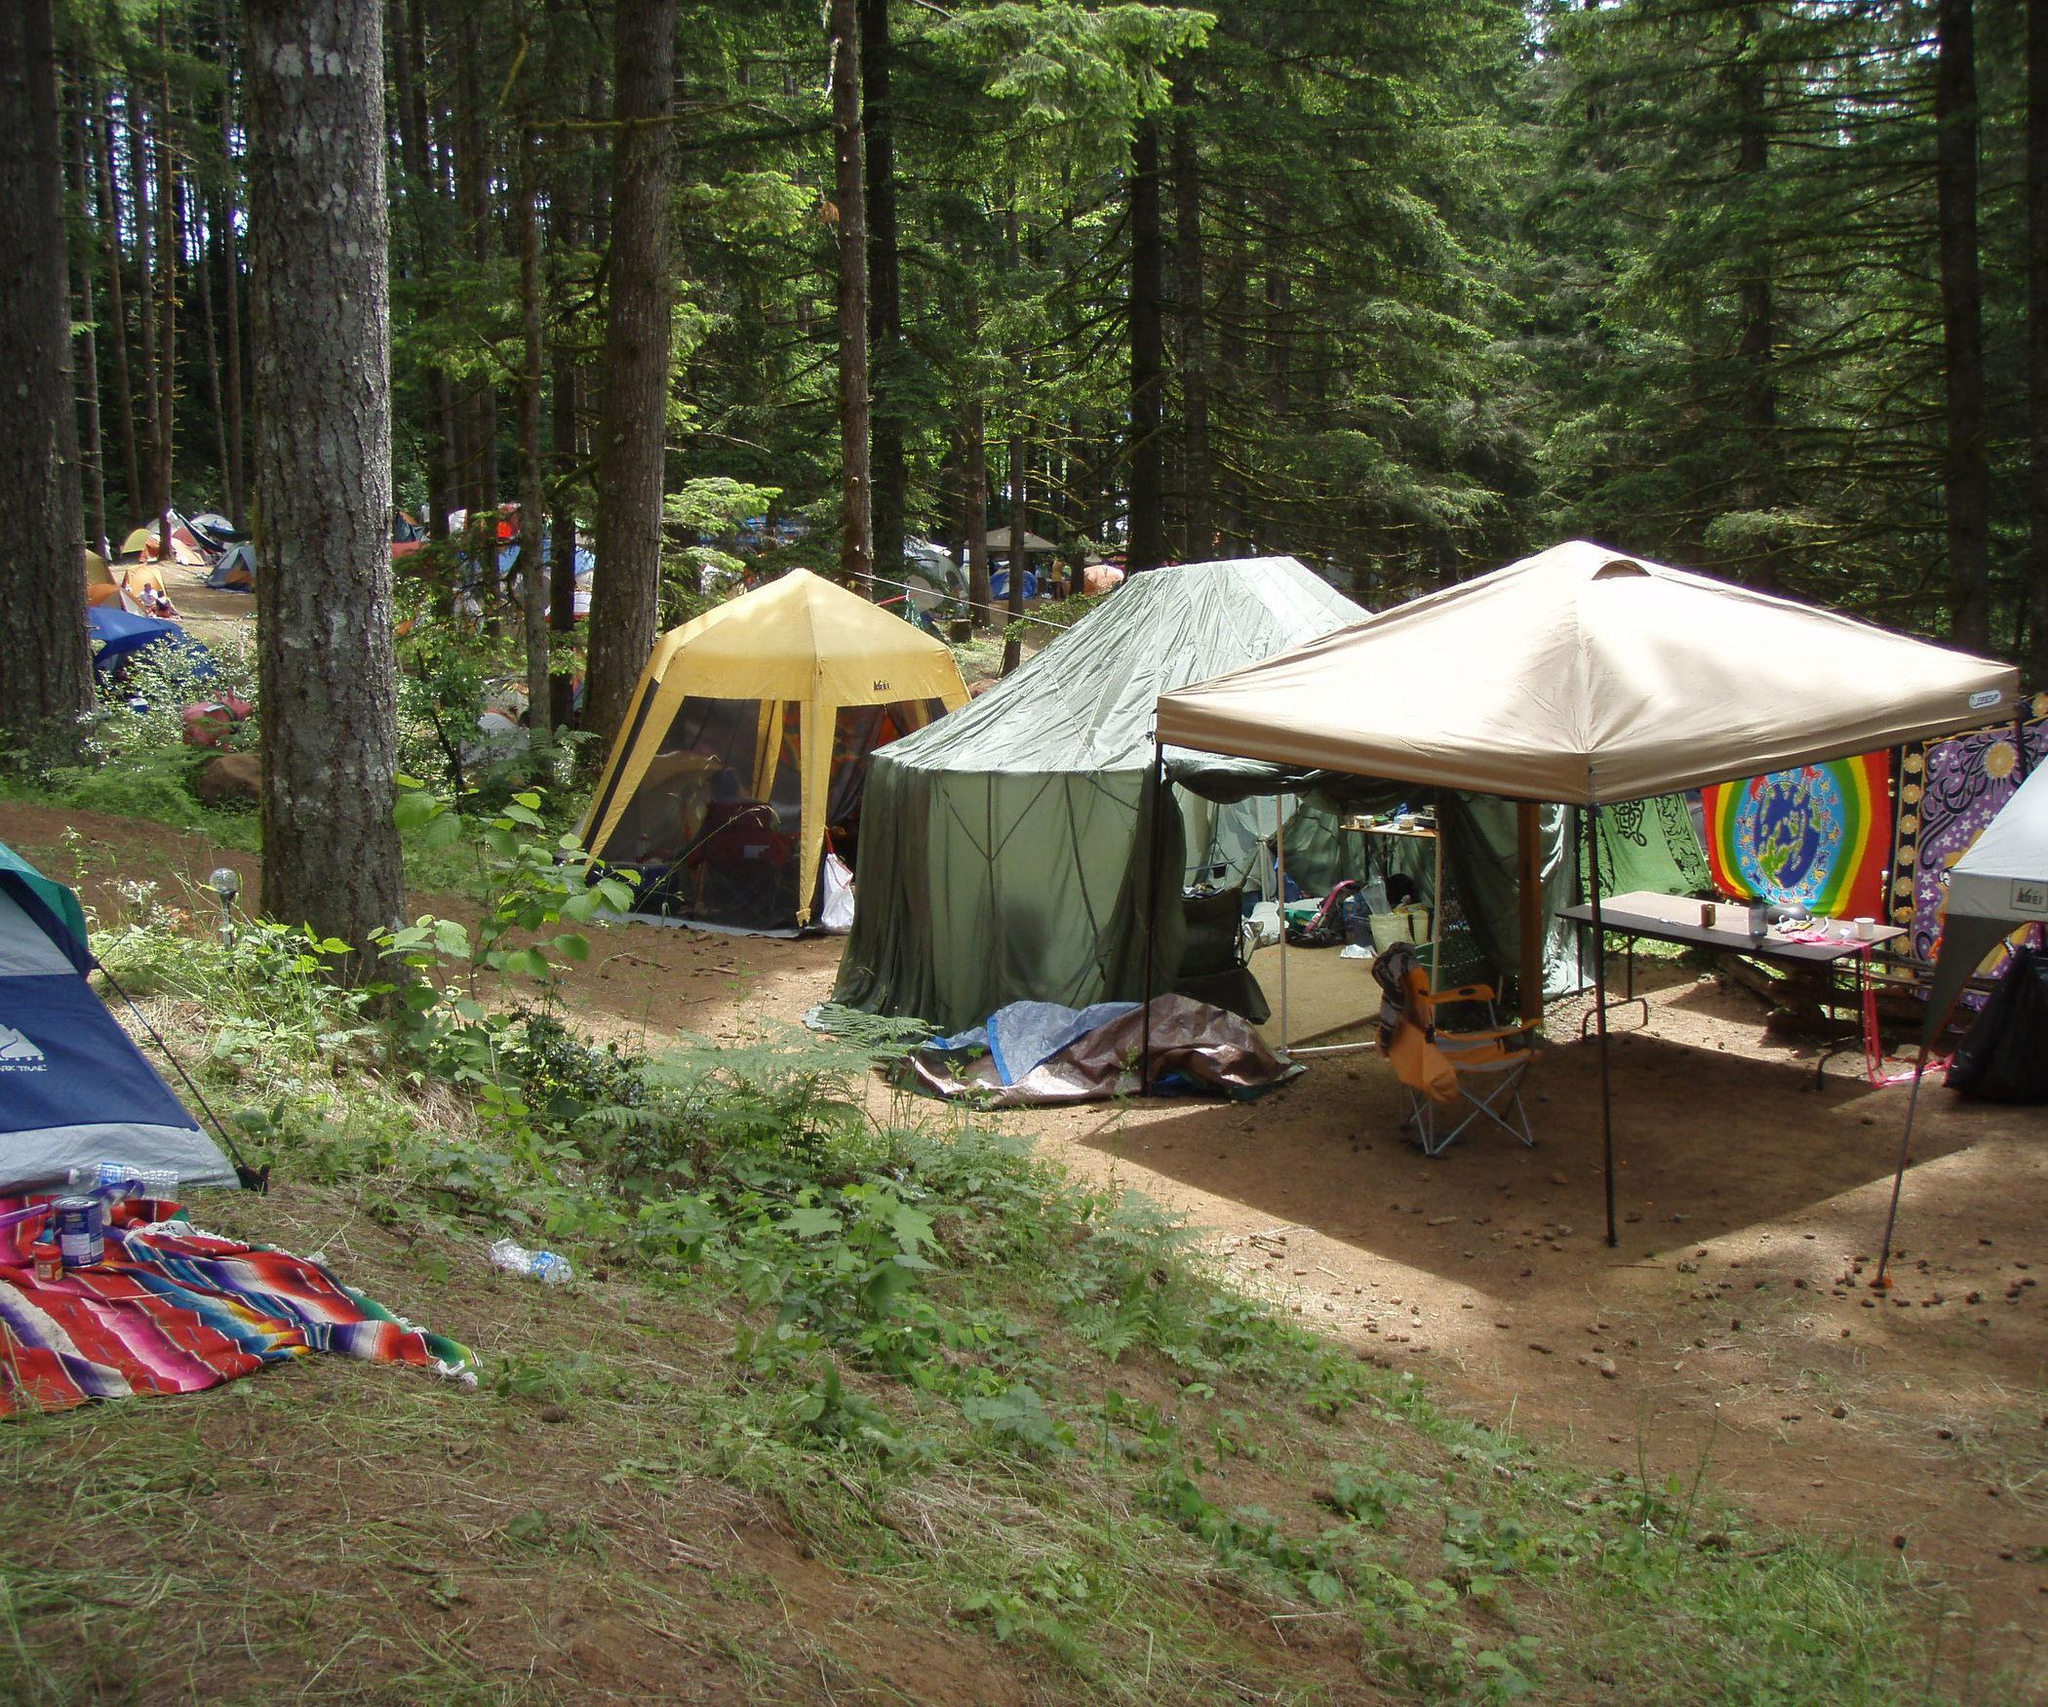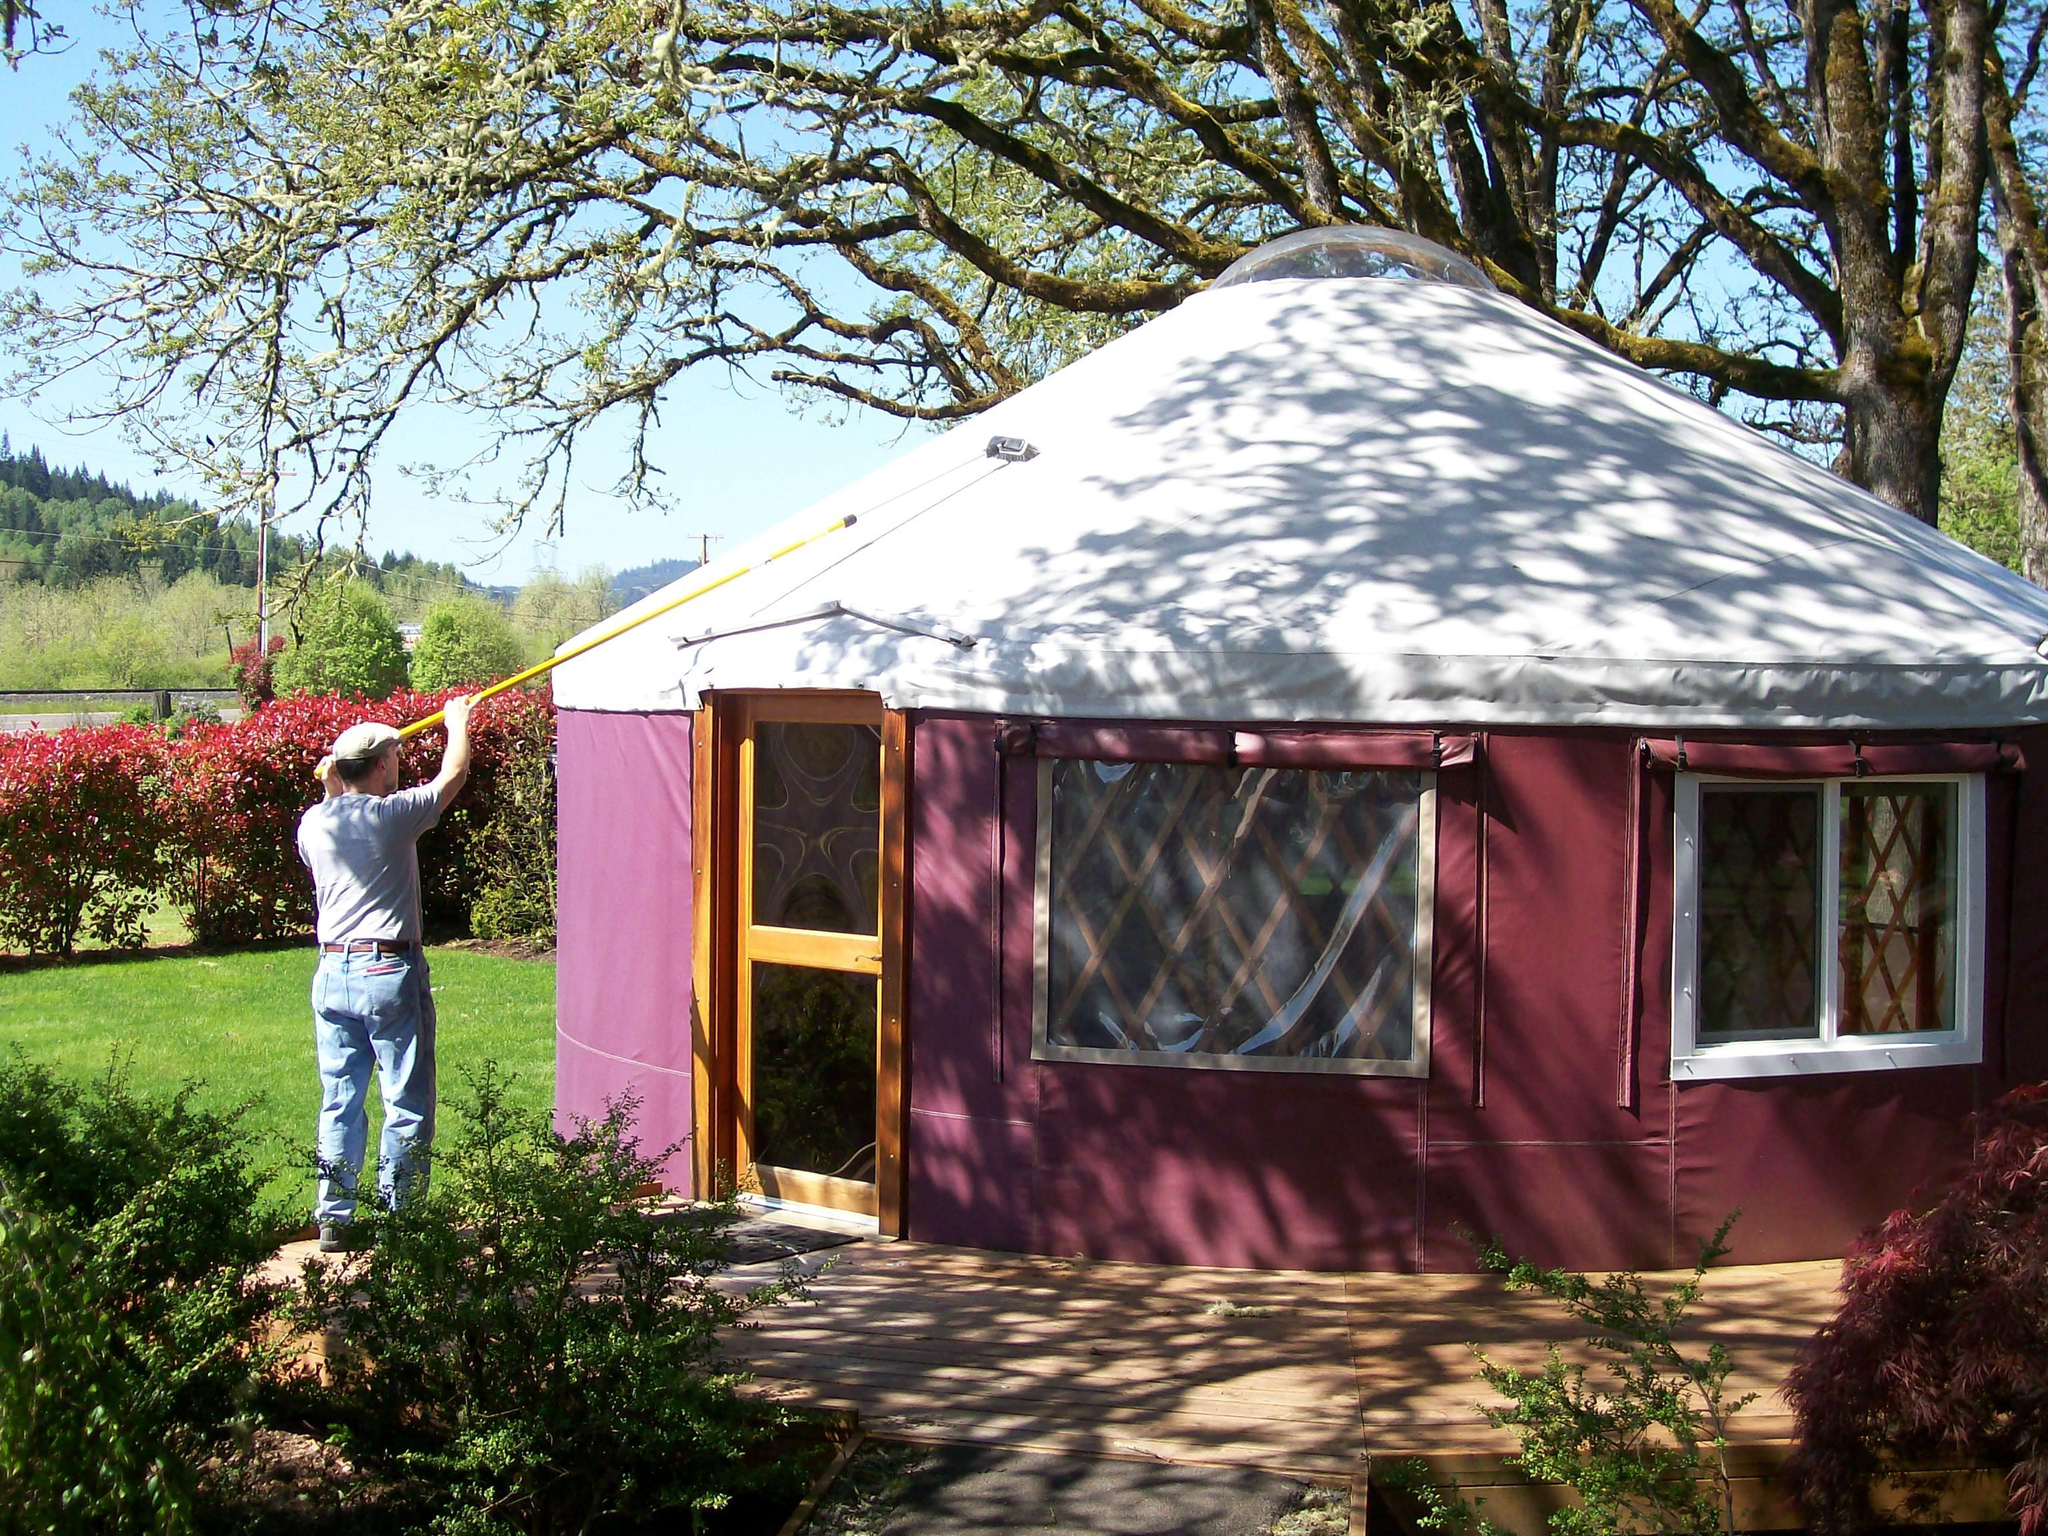The first image is the image on the left, the second image is the image on the right. Assess this claim about the two images: "At least one round house has a wooden porch area with a roof.". Correct or not? Answer yes or no. No. The first image is the image on the left, the second image is the image on the right. Analyze the images presented: Is the assertion "There is a covered wooden structure to the right of the yurt in the image on the right" valid? Answer yes or no. No. 